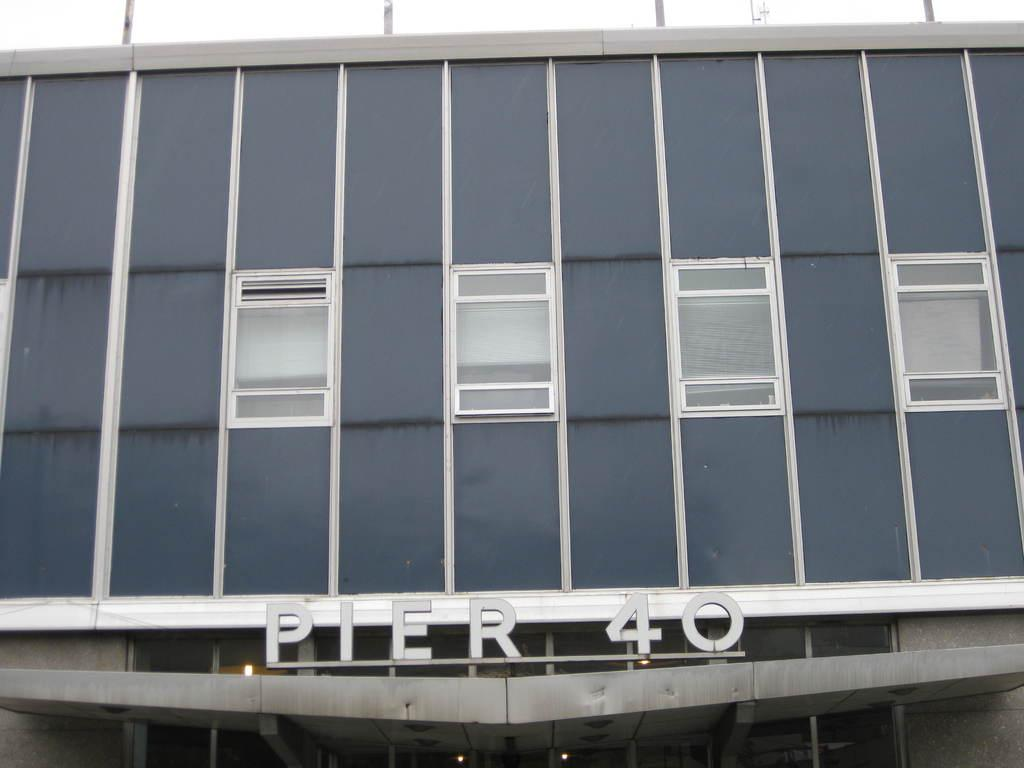What type of structure is visible in the image? There is a building in the image. What feature can be seen on the building? The building has windows. Is there any text present on the building? Yes, there is text written on the building. How many lights are visible at the bottom of the image? There are three lights at the bottom of the image. What type of offer is being made by the jail in the image? There is no jail present in the image, and therefore no offer can be made. 